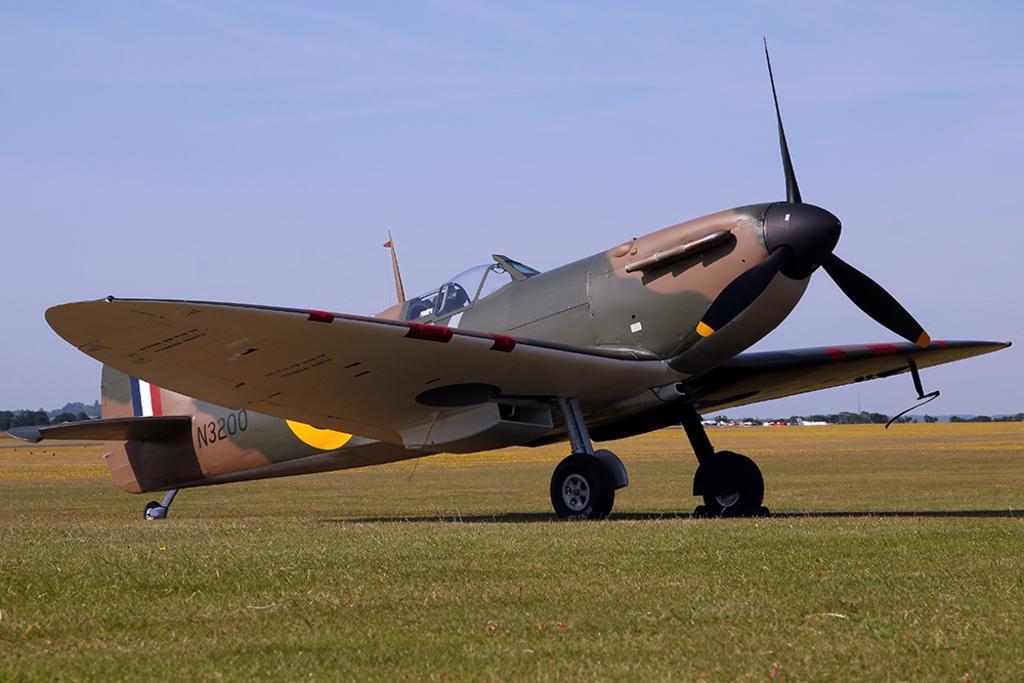Could you give a brief overview of what you see in this image? There is an aircraft with number on the ground. On the ground there is grass. In the background there are trees and sky. 